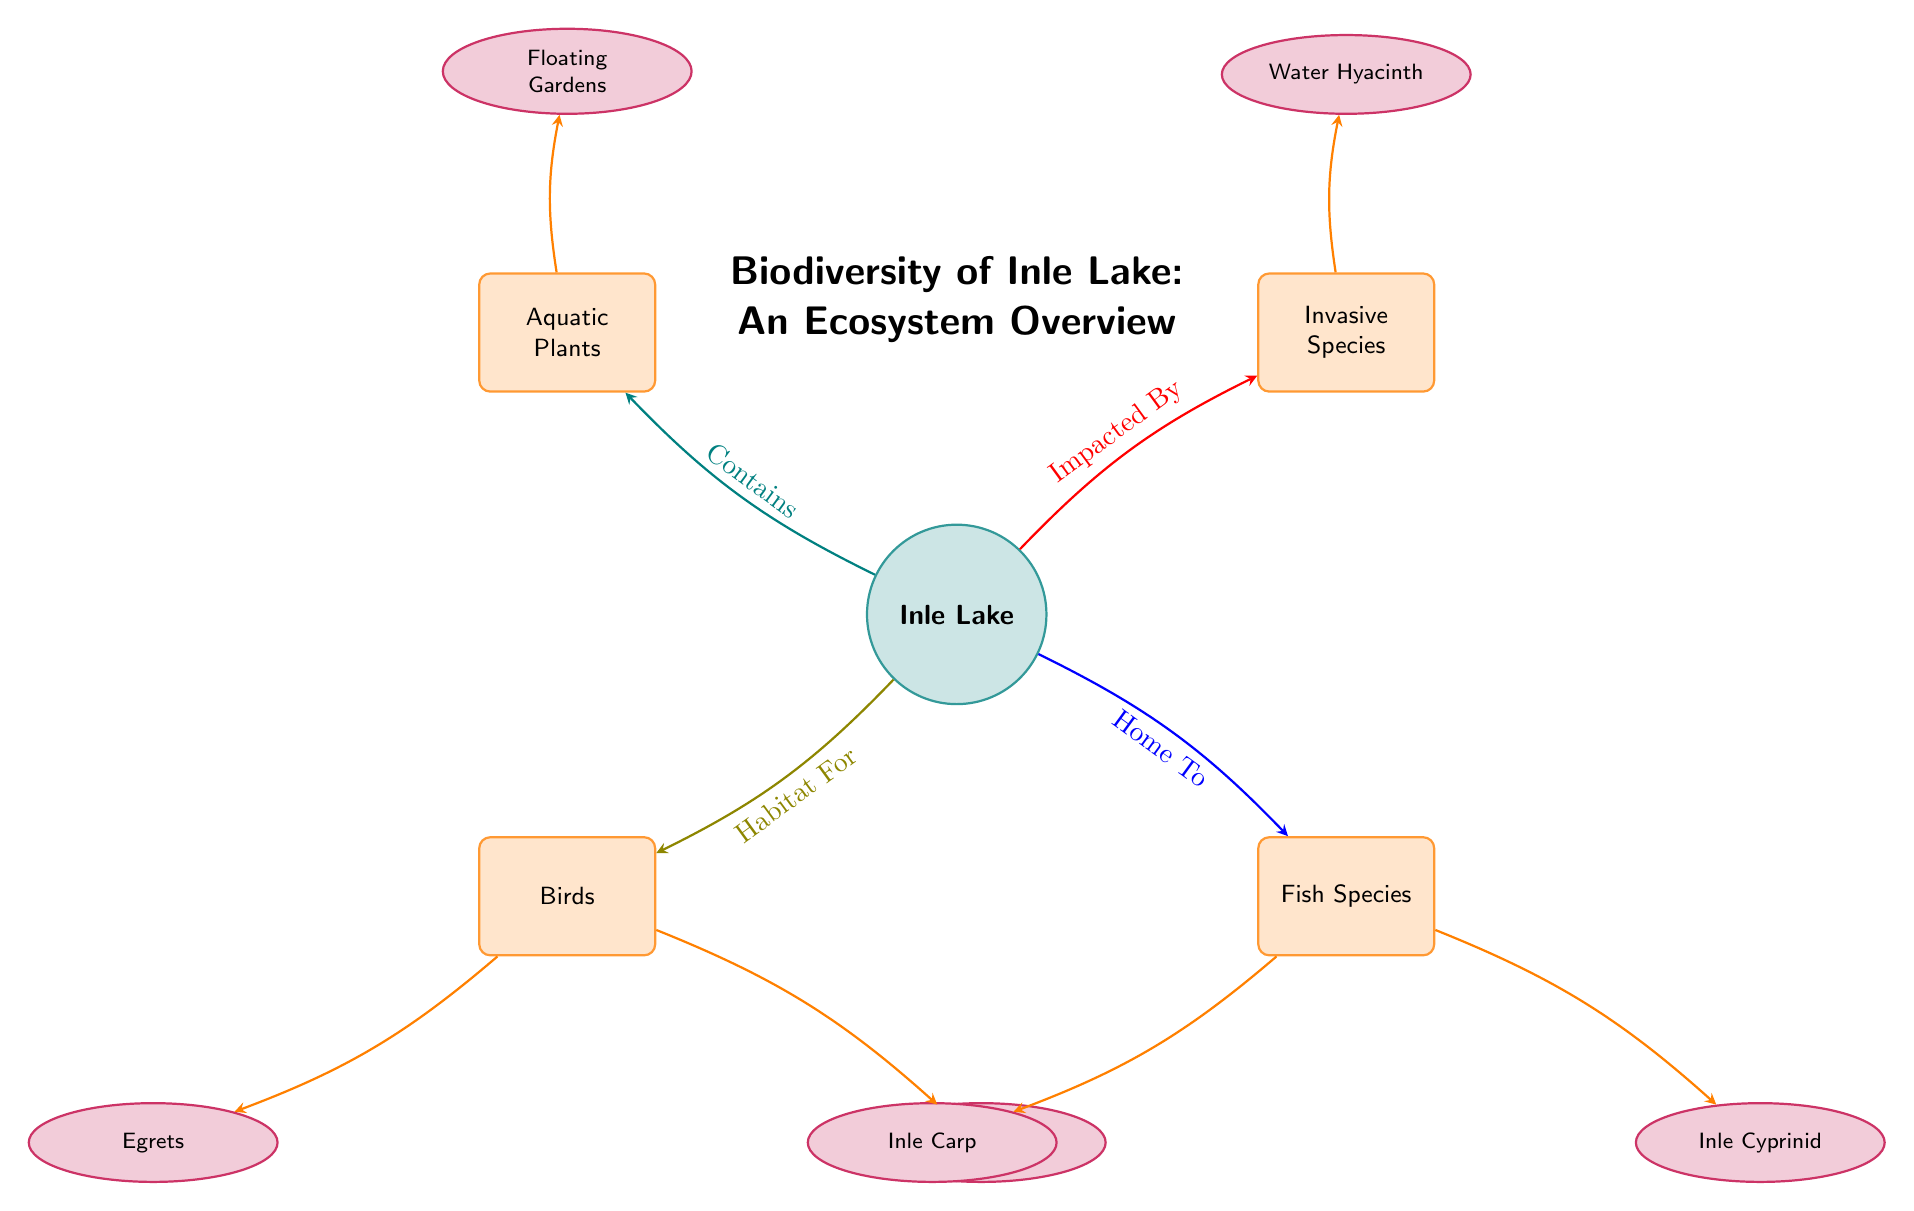What is the main subject of the diagram? The main subject of the diagram is indicated at the top as "Inle Lake," which is central to the biodiversity overview presented.
Answer: Inle Lake How many categories are shown in the diagram? The diagram contains four categories: Aquatic Plants, Invasive Species, Birds, and Fish Species. By counting the category nodes, we find there are four.
Answer: 4 What is an example of an aquatic plant listed in the diagram? The diagram specifies "Floating Gardens" as an example under the category of Aquatic Plants, positioned above the main node.
Answer: Floating Gardens Which species is impacted by the invasive species category? The diagram shows "Water Hyacinth" as an element node connected to the Invasive Species category. It represents an invasion affecting the ecosystem.
Answer: Water Hyacinth What types of birds are mentioned in the diagram? The diagram lists two specific types of birds under the Birds category, which are "Egrets" and "Coots." Both are shown as element nodes connected to the Birds category.
Answer: Egrets, Coots How many fish species are shown in the diagram? The Fish Species category includes two specific fish types listed as "Inle Carp" and "Inle Cyprinid," making a total of two fish species present in the diagram.
Answer: 2 What relationship connects Inle Lake to the aquatic plants? The diagram indicates that Inle Lake 'Contains' Aquatic Plants, which establishes a direct relationship showing the lake's role in supporting these plants.
Answer: Contains Which category is affected by invasive species? The diagram illustrates that the Invasive Species category 'Impacts' Inle Lake, indicating that the presence of invasive species affects the lake's ecosystem.
Answer: Impacts What type of diagram is this? This diagram falls under the category of a Natural Science Diagram, specifically designed to represent ecological relationships and biodiversity.
Answer: Natural Science Diagram 